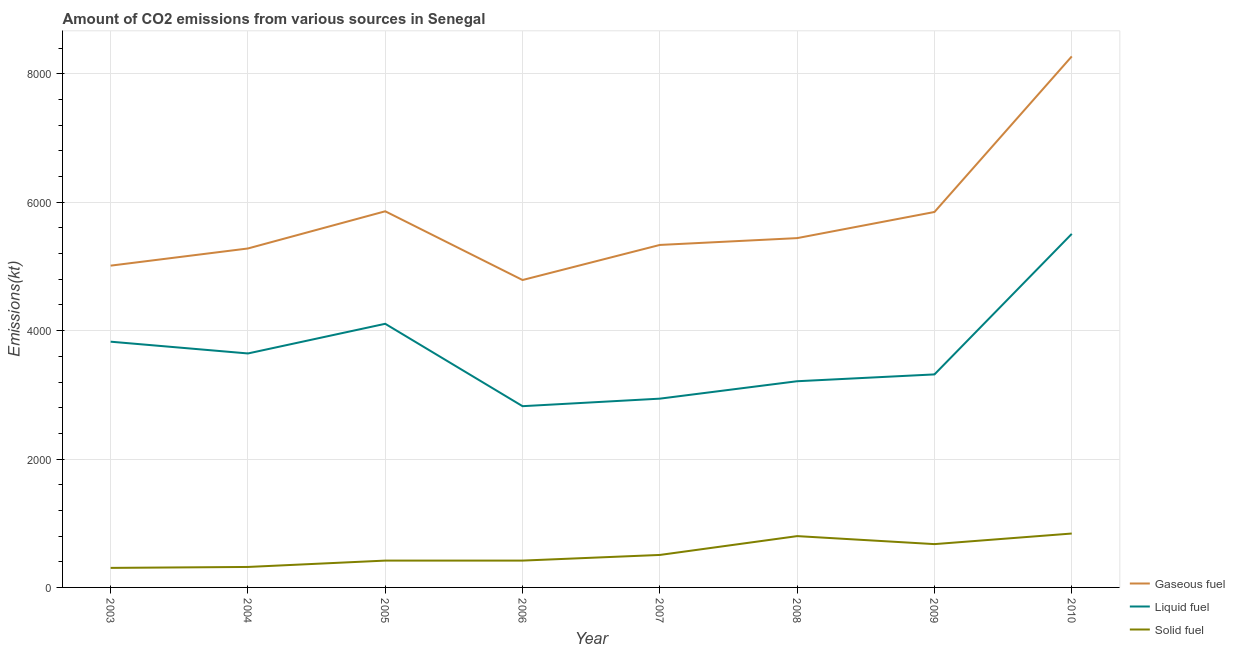How many different coloured lines are there?
Provide a succinct answer. 3. Does the line corresponding to amount of co2 emissions from gaseous fuel intersect with the line corresponding to amount of co2 emissions from solid fuel?
Keep it short and to the point. No. What is the amount of co2 emissions from liquid fuel in 2005?
Offer a very short reply. 4107.04. Across all years, what is the maximum amount of co2 emissions from gaseous fuel?
Give a very brief answer. 8272.75. Across all years, what is the minimum amount of co2 emissions from solid fuel?
Make the answer very short. 304.36. In which year was the amount of co2 emissions from solid fuel minimum?
Offer a terse response. 2003. What is the total amount of co2 emissions from gaseous fuel in the graph?
Offer a terse response. 4.58e+04. What is the difference between the amount of co2 emissions from gaseous fuel in 2004 and that in 2006?
Offer a very short reply. 491.38. What is the difference between the amount of co2 emissions from gaseous fuel in 2008 and the amount of co2 emissions from liquid fuel in 2004?
Make the answer very short. 1796.83. What is the average amount of co2 emissions from liquid fuel per year?
Give a very brief answer. 3672.96. In the year 2007, what is the difference between the amount of co2 emissions from liquid fuel and amount of co2 emissions from gaseous fuel?
Keep it short and to the point. -2394.55. What is the ratio of the amount of co2 emissions from gaseous fuel in 2003 to that in 2007?
Give a very brief answer. 0.94. Is the difference between the amount of co2 emissions from gaseous fuel in 2003 and 2005 greater than the difference between the amount of co2 emissions from solid fuel in 2003 and 2005?
Your response must be concise. No. What is the difference between the highest and the second highest amount of co2 emissions from gaseous fuel?
Keep it short and to the point. 2412.89. What is the difference between the highest and the lowest amount of co2 emissions from solid fuel?
Make the answer very short. 535.38. Does the amount of co2 emissions from gaseous fuel monotonically increase over the years?
Your answer should be very brief. No. Is the amount of co2 emissions from gaseous fuel strictly greater than the amount of co2 emissions from solid fuel over the years?
Offer a terse response. Yes. How many lines are there?
Your response must be concise. 3. Are the values on the major ticks of Y-axis written in scientific E-notation?
Ensure brevity in your answer.  No. Does the graph contain any zero values?
Offer a very short reply. No. Does the graph contain grids?
Your answer should be compact. Yes. Where does the legend appear in the graph?
Your response must be concise. Bottom right. How many legend labels are there?
Ensure brevity in your answer.  3. How are the legend labels stacked?
Offer a very short reply. Vertical. What is the title of the graph?
Provide a succinct answer. Amount of CO2 emissions from various sources in Senegal. Does "Poland" appear as one of the legend labels in the graph?
Your response must be concise. No. What is the label or title of the X-axis?
Make the answer very short. Year. What is the label or title of the Y-axis?
Offer a terse response. Emissions(kt). What is the Emissions(kt) of Gaseous fuel in 2003?
Your response must be concise. 5012.79. What is the Emissions(kt) in Liquid fuel in 2003?
Your answer should be compact. 3828.35. What is the Emissions(kt) in Solid fuel in 2003?
Make the answer very short. 304.36. What is the Emissions(kt) in Gaseous fuel in 2004?
Offer a terse response. 5280.48. What is the Emissions(kt) in Liquid fuel in 2004?
Your answer should be compact. 3645. What is the Emissions(kt) of Solid fuel in 2004?
Make the answer very short. 319.03. What is the Emissions(kt) in Gaseous fuel in 2005?
Your answer should be compact. 5859.87. What is the Emissions(kt) of Liquid fuel in 2005?
Provide a short and direct response. 4107.04. What is the Emissions(kt) in Solid fuel in 2005?
Ensure brevity in your answer.  418.04. What is the Emissions(kt) of Gaseous fuel in 2006?
Your response must be concise. 4789.1. What is the Emissions(kt) of Liquid fuel in 2006?
Your response must be concise. 2823.59. What is the Emissions(kt) of Solid fuel in 2006?
Your answer should be very brief. 418.04. What is the Emissions(kt) of Gaseous fuel in 2007?
Give a very brief answer. 5335.48. What is the Emissions(kt) of Liquid fuel in 2007?
Give a very brief answer. 2940.93. What is the Emissions(kt) in Solid fuel in 2007?
Keep it short and to the point. 506.05. What is the Emissions(kt) in Gaseous fuel in 2008?
Keep it short and to the point. 5441.83. What is the Emissions(kt) in Liquid fuel in 2008?
Make the answer very short. 3212.29. What is the Emissions(kt) in Solid fuel in 2008?
Provide a succinct answer. 799.41. What is the Emissions(kt) in Gaseous fuel in 2009?
Offer a terse response. 5848.86. What is the Emissions(kt) of Liquid fuel in 2009?
Provide a short and direct response. 3318.64. What is the Emissions(kt) of Solid fuel in 2009?
Your answer should be compact. 674.73. What is the Emissions(kt) in Gaseous fuel in 2010?
Your response must be concise. 8272.75. What is the Emissions(kt) of Liquid fuel in 2010?
Keep it short and to the point. 5507.83. What is the Emissions(kt) in Solid fuel in 2010?
Provide a short and direct response. 839.74. Across all years, what is the maximum Emissions(kt) in Gaseous fuel?
Provide a succinct answer. 8272.75. Across all years, what is the maximum Emissions(kt) in Liquid fuel?
Your answer should be compact. 5507.83. Across all years, what is the maximum Emissions(kt) in Solid fuel?
Your response must be concise. 839.74. Across all years, what is the minimum Emissions(kt) in Gaseous fuel?
Offer a terse response. 4789.1. Across all years, what is the minimum Emissions(kt) of Liquid fuel?
Offer a very short reply. 2823.59. Across all years, what is the minimum Emissions(kt) in Solid fuel?
Your response must be concise. 304.36. What is the total Emissions(kt) of Gaseous fuel in the graph?
Ensure brevity in your answer.  4.58e+04. What is the total Emissions(kt) in Liquid fuel in the graph?
Give a very brief answer. 2.94e+04. What is the total Emissions(kt) in Solid fuel in the graph?
Provide a short and direct response. 4279.39. What is the difference between the Emissions(kt) in Gaseous fuel in 2003 and that in 2004?
Give a very brief answer. -267.69. What is the difference between the Emissions(kt) of Liquid fuel in 2003 and that in 2004?
Ensure brevity in your answer.  183.35. What is the difference between the Emissions(kt) of Solid fuel in 2003 and that in 2004?
Provide a succinct answer. -14.67. What is the difference between the Emissions(kt) of Gaseous fuel in 2003 and that in 2005?
Give a very brief answer. -847.08. What is the difference between the Emissions(kt) in Liquid fuel in 2003 and that in 2005?
Provide a succinct answer. -278.69. What is the difference between the Emissions(kt) of Solid fuel in 2003 and that in 2005?
Your answer should be compact. -113.68. What is the difference between the Emissions(kt) of Gaseous fuel in 2003 and that in 2006?
Your response must be concise. 223.69. What is the difference between the Emissions(kt) of Liquid fuel in 2003 and that in 2006?
Offer a terse response. 1004.76. What is the difference between the Emissions(kt) of Solid fuel in 2003 and that in 2006?
Offer a terse response. -113.68. What is the difference between the Emissions(kt) in Gaseous fuel in 2003 and that in 2007?
Make the answer very short. -322.7. What is the difference between the Emissions(kt) of Liquid fuel in 2003 and that in 2007?
Provide a succinct answer. 887.41. What is the difference between the Emissions(kt) of Solid fuel in 2003 and that in 2007?
Provide a short and direct response. -201.69. What is the difference between the Emissions(kt) of Gaseous fuel in 2003 and that in 2008?
Your answer should be very brief. -429.04. What is the difference between the Emissions(kt) of Liquid fuel in 2003 and that in 2008?
Your answer should be very brief. 616.06. What is the difference between the Emissions(kt) of Solid fuel in 2003 and that in 2008?
Offer a very short reply. -495.05. What is the difference between the Emissions(kt) in Gaseous fuel in 2003 and that in 2009?
Offer a terse response. -836.08. What is the difference between the Emissions(kt) of Liquid fuel in 2003 and that in 2009?
Offer a terse response. 509.71. What is the difference between the Emissions(kt) of Solid fuel in 2003 and that in 2009?
Give a very brief answer. -370.37. What is the difference between the Emissions(kt) in Gaseous fuel in 2003 and that in 2010?
Keep it short and to the point. -3259.96. What is the difference between the Emissions(kt) of Liquid fuel in 2003 and that in 2010?
Offer a terse response. -1679.49. What is the difference between the Emissions(kt) in Solid fuel in 2003 and that in 2010?
Your answer should be compact. -535.38. What is the difference between the Emissions(kt) of Gaseous fuel in 2004 and that in 2005?
Your response must be concise. -579.39. What is the difference between the Emissions(kt) of Liquid fuel in 2004 and that in 2005?
Your response must be concise. -462.04. What is the difference between the Emissions(kt) in Solid fuel in 2004 and that in 2005?
Your answer should be compact. -99.01. What is the difference between the Emissions(kt) of Gaseous fuel in 2004 and that in 2006?
Your answer should be compact. 491.38. What is the difference between the Emissions(kt) in Liquid fuel in 2004 and that in 2006?
Give a very brief answer. 821.41. What is the difference between the Emissions(kt) of Solid fuel in 2004 and that in 2006?
Your answer should be compact. -99.01. What is the difference between the Emissions(kt) of Gaseous fuel in 2004 and that in 2007?
Keep it short and to the point. -55.01. What is the difference between the Emissions(kt) of Liquid fuel in 2004 and that in 2007?
Provide a succinct answer. 704.06. What is the difference between the Emissions(kt) of Solid fuel in 2004 and that in 2007?
Offer a very short reply. -187.02. What is the difference between the Emissions(kt) in Gaseous fuel in 2004 and that in 2008?
Make the answer very short. -161.35. What is the difference between the Emissions(kt) of Liquid fuel in 2004 and that in 2008?
Make the answer very short. 432.71. What is the difference between the Emissions(kt) in Solid fuel in 2004 and that in 2008?
Your response must be concise. -480.38. What is the difference between the Emissions(kt) in Gaseous fuel in 2004 and that in 2009?
Your answer should be compact. -568.38. What is the difference between the Emissions(kt) of Liquid fuel in 2004 and that in 2009?
Offer a terse response. 326.36. What is the difference between the Emissions(kt) in Solid fuel in 2004 and that in 2009?
Offer a very short reply. -355.7. What is the difference between the Emissions(kt) in Gaseous fuel in 2004 and that in 2010?
Give a very brief answer. -2992.27. What is the difference between the Emissions(kt) of Liquid fuel in 2004 and that in 2010?
Make the answer very short. -1862.84. What is the difference between the Emissions(kt) in Solid fuel in 2004 and that in 2010?
Your answer should be compact. -520.71. What is the difference between the Emissions(kt) of Gaseous fuel in 2005 and that in 2006?
Your response must be concise. 1070.76. What is the difference between the Emissions(kt) of Liquid fuel in 2005 and that in 2006?
Provide a succinct answer. 1283.45. What is the difference between the Emissions(kt) in Gaseous fuel in 2005 and that in 2007?
Give a very brief answer. 524.38. What is the difference between the Emissions(kt) of Liquid fuel in 2005 and that in 2007?
Provide a succinct answer. 1166.11. What is the difference between the Emissions(kt) of Solid fuel in 2005 and that in 2007?
Keep it short and to the point. -88.01. What is the difference between the Emissions(kt) in Gaseous fuel in 2005 and that in 2008?
Offer a very short reply. 418.04. What is the difference between the Emissions(kt) of Liquid fuel in 2005 and that in 2008?
Give a very brief answer. 894.75. What is the difference between the Emissions(kt) in Solid fuel in 2005 and that in 2008?
Provide a short and direct response. -381.37. What is the difference between the Emissions(kt) of Gaseous fuel in 2005 and that in 2009?
Your response must be concise. 11. What is the difference between the Emissions(kt) of Liquid fuel in 2005 and that in 2009?
Your answer should be very brief. 788.4. What is the difference between the Emissions(kt) in Solid fuel in 2005 and that in 2009?
Your answer should be very brief. -256.69. What is the difference between the Emissions(kt) in Gaseous fuel in 2005 and that in 2010?
Give a very brief answer. -2412.89. What is the difference between the Emissions(kt) in Liquid fuel in 2005 and that in 2010?
Provide a succinct answer. -1400.79. What is the difference between the Emissions(kt) of Solid fuel in 2005 and that in 2010?
Your response must be concise. -421.7. What is the difference between the Emissions(kt) of Gaseous fuel in 2006 and that in 2007?
Your answer should be very brief. -546.38. What is the difference between the Emissions(kt) of Liquid fuel in 2006 and that in 2007?
Provide a short and direct response. -117.34. What is the difference between the Emissions(kt) of Solid fuel in 2006 and that in 2007?
Make the answer very short. -88.01. What is the difference between the Emissions(kt) in Gaseous fuel in 2006 and that in 2008?
Provide a short and direct response. -652.73. What is the difference between the Emissions(kt) of Liquid fuel in 2006 and that in 2008?
Ensure brevity in your answer.  -388.7. What is the difference between the Emissions(kt) in Solid fuel in 2006 and that in 2008?
Provide a succinct answer. -381.37. What is the difference between the Emissions(kt) in Gaseous fuel in 2006 and that in 2009?
Your answer should be very brief. -1059.76. What is the difference between the Emissions(kt) in Liquid fuel in 2006 and that in 2009?
Offer a terse response. -495.05. What is the difference between the Emissions(kt) of Solid fuel in 2006 and that in 2009?
Keep it short and to the point. -256.69. What is the difference between the Emissions(kt) of Gaseous fuel in 2006 and that in 2010?
Offer a very short reply. -3483.65. What is the difference between the Emissions(kt) in Liquid fuel in 2006 and that in 2010?
Offer a terse response. -2684.24. What is the difference between the Emissions(kt) in Solid fuel in 2006 and that in 2010?
Your answer should be very brief. -421.7. What is the difference between the Emissions(kt) of Gaseous fuel in 2007 and that in 2008?
Provide a short and direct response. -106.34. What is the difference between the Emissions(kt) of Liquid fuel in 2007 and that in 2008?
Provide a short and direct response. -271.36. What is the difference between the Emissions(kt) in Solid fuel in 2007 and that in 2008?
Provide a succinct answer. -293.36. What is the difference between the Emissions(kt) in Gaseous fuel in 2007 and that in 2009?
Provide a succinct answer. -513.38. What is the difference between the Emissions(kt) in Liquid fuel in 2007 and that in 2009?
Provide a short and direct response. -377.7. What is the difference between the Emissions(kt) of Solid fuel in 2007 and that in 2009?
Provide a succinct answer. -168.68. What is the difference between the Emissions(kt) in Gaseous fuel in 2007 and that in 2010?
Your answer should be compact. -2937.27. What is the difference between the Emissions(kt) in Liquid fuel in 2007 and that in 2010?
Give a very brief answer. -2566.9. What is the difference between the Emissions(kt) of Solid fuel in 2007 and that in 2010?
Your answer should be very brief. -333.7. What is the difference between the Emissions(kt) in Gaseous fuel in 2008 and that in 2009?
Ensure brevity in your answer.  -407.04. What is the difference between the Emissions(kt) in Liquid fuel in 2008 and that in 2009?
Provide a short and direct response. -106.34. What is the difference between the Emissions(kt) in Solid fuel in 2008 and that in 2009?
Your answer should be compact. 124.68. What is the difference between the Emissions(kt) of Gaseous fuel in 2008 and that in 2010?
Ensure brevity in your answer.  -2830.92. What is the difference between the Emissions(kt) of Liquid fuel in 2008 and that in 2010?
Ensure brevity in your answer.  -2295.54. What is the difference between the Emissions(kt) of Solid fuel in 2008 and that in 2010?
Provide a succinct answer. -40.34. What is the difference between the Emissions(kt) in Gaseous fuel in 2009 and that in 2010?
Provide a succinct answer. -2423.89. What is the difference between the Emissions(kt) in Liquid fuel in 2009 and that in 2010?
Offer a terse response. -2189.2. What is the difference between the Emissions(kt) of Solid fuel in 2009 and that in 2010?
Make the answer very short. -165.01. What is the difference between the Emissions(kt) in Gaseous fuel in 2003 and the Emissions(kt) in Liquid fuel in 2004?
Give a very brief answer. 1367.79. What is the difference between the Emissions(kt) in Gaseous fuel in 2003 and the Emissions(kt) in Solid fuel in 2004?
Make the answer very short. 4693.76. What is the difference between the Emissions(kt) in Liquid fuel in 2003 and the Emissions(kt) in Solid fuel in 2004?
Keep it short and to the point. 3509.32. What is the difference between the Emissions(kt) in Gaseous fuel in 2003 and the Emissions(kt) in Liquid fuel in 2005?
Your answer should be compact. 905.75. What is the difference between the Emissions(kt) in Gaseous fuel in 2003 and the Emissions(kt) in Solid fuel in 2005?
Keep it short and to the point. 4594.75. What is the difference between the Emissions(kt) of Liquid fuel in 2003 and the Emissions(kt) of Solid fuel in 2005?
Your answer should be compact. 3410.31. What is the difference between the Emissions(kt) of Gaseous fuel in 2003 and the Emissions(kt) of Liquid fuel in 2006?
Make the answer very short. 2189.2. What is the difference between the Emissions(kt) of Gaseous fuel in 2003 and the Emissions(kt) of Solid fuel in 2006?
Give a very brief answer. 4594.75. What is the difference between the Emissions(kt) in Liquid fuel in 2003 and the Emissions(kt) in Solid fuel in 2006?
Provide a short and direct response. 3410.31. What is the difference between the Emissions(kt) of Gaseous fuel in 2003 and the Emissions(kt) of Liquid fuel in 2007?
Make the answer very short. 2071.86. What is the difference between the Emissions(kt) in Gaseous fuel in 2003 and the Emissions(kt) in Solid fuel in 2007?
Provide a short and direct response. 4506.74. What is the difference between the Emissions(kt) of Liquid fuel in 2003 and the Emissions(kt) of Solid fuel in 2007?
Provide a short and direct response. 3322.3. What is the difference between the Emissions(kt) in Gaseous fuel in 2003 and the Emissions(kt) in Liquid fuel in 2008?
Your answer should be very brief. 1800.5. What is the difference between the Emissions(kt) of Gaseous fuel in 2003 and the Emissions(kt) of Solid fuel in 2008?
Your answer should be very brief. 4213.38. What is the difference between the Emissions(kt) in Liquid fuel in 2003 and the Emissions(kt) in Solid fuel in 2008?
Offer a terse response. 3028.94. What is the difference between the Emissions(kt) in Gaseous fuel in 2003 and the Emissions(kt) in Liquid fuel in 2009?
Offer a very short reply. 1694.15. What is the difference between the Emissions(kt) of Gaseous fuel in 2003 and the Emissions(kt) of Solid fuel in 2009?
Offer a terse response. 4338.06. What is the difference between the Emissions(kt) of Liquid fuel in 2003 and the Emissions(kt) of Solid fuel in 2009?
Your answer should be very brief. 3153.62. What is the difference between the Emissions(kt) of Gaseous fuel in 2003 and the Emissions(kt) of Liquid fuel in 2010?
Offer a terse response. -495.05. What is the difference between the Emissions(kt) of Gaseous fuel in 2003 and the Emissions(kt) of Solid fuel in 2010?
Make the answer very short. 4173.05. What is the difference between the Emissions(kt) of Liquid fuel in 2003 and the Emissions(kt) of Solid fuel in 2010?
Provide a succinct answer. 2988.61. What is the difference between the Emissions(kt) in Gaseous fuel in 2004 and the Emissions(kt) in Liquid fuel in 2005?
Your answer should be compact. 1173.44. What is the difference between the Emissions(kt) in Gaseous fuel in 2004 and the Emissions(kt) in Solid fuel in 2005?
Offer a terse response. 4862.44. What is the difference between the Emissions(kt) in Liquid fuel in 2004 and the Emissions(kt) in Solid fuel in 2005?
Provide a short and direct response. 3226.96. What is the difference between the Emissions(kt) in Gaseous fuel in 2004 and the Emissions(kt) in Liquid fuel in 2006?
Give a very brief answer. 2456.89. What is the difference between the Emissions(kt) of Gaseous fuel in 2004 and the Emissions(kt) of Solid fuel in 2006?
Offer a very short reply. 4862.44. What is the difference between the Emissions(kt) of Liquid fuel in 2004 and the Emissions(kt) of Solid fuel in 2006?
Your answer should be compact. 3226.96. What is the difference between the Emissions(kt) of Gaseous fuel in 2004 and the Emissions(kt) of Liquid fuel in 2007?
Your response must be concise. 2339.55. What is the difference between the Emissions(kt) in Gaseous fuel in 2004 and the Emissions(kt) in Solid fuel in 2007?
Your answer should be compact. 4774.43. What is the difference between the Emissions(kt) in Liquid fuel in 2004 and the Emissions(kt) in Solid fuel in 2007?
Offer a very short reply. 3138.95. What is the difference between the Emissions(kt) of Gaseous fuel in 2004 and the Emissions(kt) of Liquid fuel in 2008?
Your response must be concise. 2068.19. What is the difference between the Emissions(kt) in Gaseous fuel in 2004 and the Emissions(kt) in Solid fuel in 2008?
Offer a very short reply. 4481.07. What is the difference between the Emissions(kt) of Liquid fuel in 2004 and the Emissions(kt) of Solid fuel in 2008?
Ensure brevity in your answer.  2845.59. What is the difference between the Emissions(kt) in Gaseous fuel in 2004 and the Emissions(kt) in Liquid fuel in 2009?
Offer a very short reply. 1961.85. What is the difference between the Emissions(kt) in Gaseous fuel in 2004 and the Emissions(kt) in Solid fuel in 2009?
Provide a short and direct response. 4605.75. What is the difference between the Emissions(kt) in Liquid fuel in 2004 and the Emissions(kt) in Solid fuel in 2009?
Your answer should be compact. 2970.27. What is the difference between the Emissions(kt) of Gaseous fuel in 2004 and the Emissions(kt) of Liquid fuel in 2010?
Your answer should be compact. -227.35. What is the difference between the Emissions(kt) of Gaseous fuel in 2004 and the Emissions(kt) of Solid fuel in 2010?
Give a very brief answer. 4440.74. What is the difference between the Emissions(kt) of Liquid fuel in 2004 and the Emissions(kt) of Solid fuel in 2010?
Your answer should be compact. 2805.26. What is the difference between the Emissions(kt) of Gaseous fuel in 2005 and the Emissions(kt) of Liquid fuel in 2006?
Make the answer very short. 3036.28. What is the difference between the Emissions(kt) of Gaseous fuel in 2005 and the Emissions(kt) of Solid fuel in 2006?
Provide a short and direct response. 5441.83. What is the difference between the Emissions(kt) in Liquid fuel in 2005 and the Emissions(kt) in Solid fuel in 2006?
Offer a terse response. 3689. What is the difference between the Emissions(kt) in Gaseous fuel in 2005 and the Emissions(kt) in Liquid fuel in 2007?
Your answer should be compact. 2918.93. What is the difference between the Emissions(kt) in Gaseous fuel in 2005 and the Emissions(kt) in Solid fuel in 2007?
Keep it short and to the point. 5353.82. What is the difference between the Emissions(kt) in Liquid fuel in 2005 and the Emissions(kt) in Solid fuel in 2007?
Make the answer very short. 3600.99. What is the difference between the Emissions(kt) of Gaseous fuel in 2005 and the Emissions(kt) of Liquid fuel in 2008?
Give a very brief answer. 2647.57. What is the difference between the Emissions(kt) of Gaseous fuel in 2005 and the Emissions(kt) of Solid fuel in 2008?
Provide a short and direct response. 5060.46. What is the difference between the Emissions(kt) in Liquid fuel in 2005 and the Emissions(kt) in Solid fuel in 2008?
Ensure brevity in your answer.  3307.63. What is the difference between the Emissions(kt) in Gaseous fuel in 2005 and the Emissions(kt) in Liquid fuel in 2009?
Ensure brevity in your answer.  2541.23. What is the difference between the Emissions(kt) of Gaseous fuel in 2005 and the Emissions(kt) of Solid fuel in 2009?
Offer a very short reply. 5185.14. What is the difference between the Emissions(kt) of Liquid fuel in 2005 and the Emissions(kt) of Solid fuel in 2009?
Provide a succinct answer. 3432.31. What is the difference between the Emissions(kt) of Gaseous fuel in 2005 and the Emissions(kt) of Liquid fuel in 2010?
Make the answer very short. 352.03. What is the difference between the Emissions(kt) of Gaseous fuel in 2005 and the Emissions(kt) of Solid fuel in 2010?
Offer a terse response. 5020.12. What is the difference between the Emissions(kt) of Liquid fuel in 2005 and the Emissions(kt) of Solid fuel in 2010?
Keep it short and to the point. 3267.3. What is the difference between the Emissions(kt) in Gaseous fuel in 2006 and the Emissions(kt) in Liquid fuel in 2007?
Give a very brief answer. 1848.17. What is the difference between the Emissions(kt) in Gaseous fuel in 2006 and the Emissions(kt) in Solid fuel in 2007?
Your response must be concise. 4283.06. What is the difference between the Emissions(kt) in Liquid fuel in 2006 and the Emissions(kt) in Solid fuel in 2007?
Offer a very short reply. 2317.54. What is the difference between the Emissions(kt) of Gaseous fuel in 2006 and the Emissions(kt) of Liquid fuel in 2008?
Your answer should be compact. 1576.81. What is the difference between the Emissions(kt) of Gaseous fuel in 2006 and the Emissions(kt) of Solid fuel in 2008?
Offer a very short reply. 3989.7. What is the difference between the Emissions(kt) in Liquid fuel in 2006 and the Emissions(kt) in Solid fuel in 2008?
Your response must be concise. 2024.18. What is the difference between the Emissions(kt) in Gaseous fuel in 2006 and the Emissions(kt) in Liquid fuel in 2009?
Provide a succinct answer. 1470.47. What is the difference between the Emissions(kt) of Gaseous fuel in 2006 and the Emissions(kt) of Solid fuel in 2009?
Ensure brevity in your answer.  4114.37. What is the difference between the Emissions(kt) of Liquid fuel in 2006 and the Emissions(kt) of Solid fuel in 2009?
Provide a succinct answer. 2148.86. What is the difference between the Emissions(kt) in Gaseous fuel in 2006 and the Emissions(kt) in Liquid fuel in 2010?
Offer a very short reply. -718.73. What is the difference between the Emissions(kt) of Gaseous fuel in 2006 and the Emissions(kt) of Solid fuel in 2010?
Offer a terse response. 3949.36. What is the difference between the Emissions(kt) in Liquid fuel in 2006 and the Emissions(kt) in Solid fuel in 2010?
Make the answer very short. 1983.85. What is the difference between the Emissions(kt) in Gaseous fuel in 2007 and the Emissions(kt) in Liquid fuel in 2008?
Provide a succinct answer. 2123.19. What is the difference between the Emissions(kt) in Gaseous fuel in 2007 and the Emissions(kt) in Solid fuel in 2008?
Your response must be concise. 4536.08. What is the difference between the Emissions(kt) of Liquid fuel in 2007 and the Emissions(kt) of Solid fuel in 2008?
Provide a succinct answer. 2141.53. What is the difference between the Emissions(kt) in Gaseous fuel in 2007 and the Emissions(kt) in Liquid fuel in 2009?
Keep it short and to the point. 2016.85. What is the difference between the Emissions(kt) in Gaseous fuel in 2007 and the Emissions(kt) in Solid fuel in 2009?
Offer a terse response. 4660.76. What is the difference between the Emissions(kt) of Liquid fuel in 2007 and the Emissions(kt) of Solid fuel in 2009?
Provide a short and direct response. 2266.21. What is the difference between the Emissions(kt) in Gaseous fuel in 2007 and the Emissions(kt) in Liquid fuel in 2010?
Offer a terse response. -172.35. What is the difference between the Emissions(kt) of Gaseous fuel in 2007 and the Emissions(kt) of Solid fuel in 2010?
Provide a succinct answer. 4495.74. What is the difference between the Emissions(kt) in Liquid fuel in 2007 and the Emissions(kt) in Solid fuel in 2010?
Provide a short and direct response. 2101.19. What is the difference between the Emissions(kt) in Gaseous fuel in 2008 and the Emissions(kt) in Liquid fuel in 2009?
Make the answer very short. 2123.19. What is the difference between the Emissions(kt) in Gaseous fuel in 2008 and the Emissions(kt) in Solid fuel in 2009?
Provide a succinct answer. 4767.1. What is the difference between the Emissions(kt) in Liquid fuel in 2008 and the Emissions(kt) in Solid fuel in 2009?
Provide a succinct answer. 2537.56. What is the difference between the Emissions(kt) of Gaseous fuel in 2008 and the Emissions(kt) of Liquid fuel in 2010?
Keep it short and to the point. -66.01. What is the difference between the Emissions(kt) in Gaseous fuel in 2008 and the Emissions(kt) in Solid fuel in 2010?
Your answer should be very brief. 4602.09. What is the difference between the Emissions(kt) of Liquid fuel in 2008 and the Emissions(kt) of Solid fuel in 2010?
Your response must be concise. 2372.55. What is the difference between the Emissions(kt) in Gaseous fuel in 2009 and the Emissions(kt) in Liquid fuel in 2010?
Your answer should be compact. 341.03. What is the difference between the Emissions(kt) in Gaseous fuel in 2009 and the Emissions(kt) in Solid fuel in 2010?
Ensure brevity in your answer.  5009.12. What is the difference between the Emissions(kt) in Liquid fuel in 2009 and the Emissions(kt) in Solid fuel in 2010?
Provide a short and direct response. 2478.89. What is the average Emissions(kt) in Gaseous fuel per year?
Give a very brief answer. 5730.15. What is the average Emissions(kt) in Liquid fuel per year?
Provide a short and direct response. 3672.96. What is the average Emissions(kt) in Solid fuel per year?
Ensure brevity in your answer.  534.92. In the year 2003, what is the difference between the Emissions(kt) in Gaseous fuel and Emissions(kt) in Liquid fuel?
Your answer should be compact. 1184.44. In the year 2003, what is the difference between the Emissions(kt) of Gaseous fuel and Emissions(kt) of Solid fuel?
Ensure brevity in your answer.  4708.43. In the year 2003, what is the difference between the Emissions(kt) of Liquid fuel and Emissions(kt) of Solid fuel?
Provide a short and direct response. 3523.99. In the year 2004, what is the difference between the Emissions(kt) of Gaseous fuel and Emissions(kt) of Liquid fuel?
Ensure brevity in your answer.  1635.48. In the year 2004, what is the difference between the Emissions(kt) of Gaseous fuel and Emissions(kt) of Solid fuel?
Your answer should be very brief. 4961.45. In the year 2004, what is the difference between the Emissions(kt) of Liquid fuel and Emissions(kt) of Solid fuel?
Give a very brief answer. 3325.97. In the year 2005, what is the difference between the Emissions(kt) of Gaseous fuel and Emissions(kt) of Liquid fuel?
Make the answer very short. 1752.83. In the year 2005, what is the difference between the Emissions(kt) of Gaseous fuel and Emissions(kt) of Solid fuel?
Your answer should be very brief. 5441.83. In the year 2005, what is the difference between the Emissions(kt) in Liquid fuel and Emissions(kt) in Solid fuel?
Ensure brevity in your answer.  3689. In the year 2006, what is the difference between the Emissions(kt) in Gaseous fuel and Emissions(kt) in Liquid fuel?
Offer a very short reply. 1965.51. In the year 2006, what is the difference between the Emissions(kt) in Gaseous fuel and Emissions(kt) in Solid fuel?
Your response must be concise. 4371.06. In the year 2006, what is the difference between the Emissions(kt) of Liquid fuel and Emissions(kt) of Solid fuel?
Offer a very short reply. 2405.55. In the year 2007, what is the difference between the Emissions(kt) of Gaseous fuel and Emissions(kt) of Liquid fuel?
Make the answer very short. 2394.55. In the year 2007, what is the difference between the Emissions(kt) in Gaseous fuel and Emissions(kt) in Solid fuel?
Offer a very short reply. 4829.44. In the year 2007, what is the difference between the Emissions(kt) of Liquid fuel and Emissions(kt) of Solid fuel?
Your answer should be compact. 2434.89. In the year 2008, what is the difference between the Emissions(kt) of Gaseous fuel and Emissions(kt) of Liquid fuel?
Offer a terse response. 2229.54. In the year 2008, what is the difference between the Emissions(kt) in Gaseous fuel and Emissions(kt) in Solid fuel?
Offer a terse response. 4642.42. In the year 2008, what is the difference between the Emissions(kt) in Liquid fuel and Emissions(kt) in Solid fuel?
Provide a short and direct response. 2412.89. In the year 2009, what is the difference between the Emissions(kt) in Gaseous fuel and Emissions(kt) in Liquid fuel?
Provide a succinct answer. 2530.23. In the year 2009, what is the difference between the Emissions(kt) in Gaseous fuel and Emissions(kt) in Solid fuel?
Ensure brevity in your answer.  5174.14. In the year 2009, what is the difference between the Emissions(kt) in Liquid fuel and Emissions(kt) in Solid fuel?
Give a very brief answer. 2643.91. In the year 2010, what is the difference between the Emissions(kt) in Gaseous fuel and Emissions(kt) in Liquid fuel?
Ensure brevity in your answer.  2764.92. In the year 2010, what is the difference between the Emissions(kt) of Gaseous fuel and Emissions(kt) of Solid fuel?
Offer a very short reply. 7433.01. In the year 2010, what is the difference between the Emissions(kt) of Liquid fuel and Emissions(kt) of Solid fuel?
Provide a succinct answer. 4668.09. What is the ratio of the Emissions(kt) of Gaseous fuel in 2003 to that in 2004?
Make the answer very short. 0.95. What is the ratio of the Emissions(kt) in Liquid fuel in 2003 to that in 2004?
Your answer should be very brief. 1.05. What is the ratio of the Emissions(kt) in Solid fuel in 2003 to that in 2004?
Make the answer very short. 0.95. What is the ratio of the Emissions(kt) of Gaseous fuel in 2003 to that in 2005?
Provide a short and direct response. 0.86. What is the ratio of the Emissions(kt) of Liquid fuel in 2003 to that in 2005?
Make the answer very short. 0.93. What is the ratio of the Emissions(kt) of Solid fuel in 2003 to that in 2005?
Your response must be concise. 0.73. What is the ratio of the Emissions(kt) of Gaseous fuel in 2003 to that in 2006?
Ensure brevity in your answer.  1.05. What is the ratio of the Emissions(kt) in Liquid fuel in 2003 to that in 2006?
Your answer should be compact. 1.36. What is the ratio of the Emissions(kt) in Solid fuel in 2003 to that in 2006?
Provide a short and direct response. 0.73. What is the ratio of the Emissions(kt) in Gaseous fuel in 2003 to that in 2007?
Your response must be concise. 0.94. What is the ratio of the Emissions(kt) of Liquid fuel in 2003 to that in 2007?
Give a very brief answer. 1.3. What is the ratio of the Emissions(kt) of Solid fuel in 2003 to that in 2007?
Offer a very short reply. 0.6. What is the ratio of the Emissions(kt) in Gaseous fuel in 2003 to that in 2008?
Your answer should be compact. 0.92. What is the ratio of the Emissions(kt) of Liquid fuel in 2003 to that in 2008?
Provide a short and direct response. 1.19. What is the ratio of the Emissions(kt) of Solid fuel in 2003 to that in 2008?
Provide a short and direct response. 0.38. What is the ratio of the Emissions(kt) of Gaseous fuel in 2003 to that in 2009?
Your response must be concise. 0.86. What is the ratio of the Emissions(kt) in Liquid fuel in 2003 to that in 2009?
Your response must be concise. 1.15. What is the ratio of the Emissions(kt) of Solid fuel in 2003 to that in 2009?
Give a very brief answer. 0.45. What is the ratio of the Emissions(kt) of Gaseous fuel in 2003 to that in 2010?
Your answer should be very brief. 0.61. What is the ratio of the Emissions(kt) in Liquid fuel in 2003 to that in 2010?
Keep it short and to the point. 0.7. What is the ratio of the Emissions(kt) in Solid fuel in 2003 to that in 2010?
Your answer should be compact. 0.36. What is the ratio of the Emissions(kt) in Gaseous fuel in 2004 to that in 2005?
Your response must be concise. 0.9. What is the ratio of the Emissions(kt) in Liquid fuel in 2004 to that in 2005?
Give a very brief answer. 0.89. What is the ratio of the Emissions(kt) in Solid fuel in 2004 to that in 2005?
Your response must be concise. 0.76. What is the ratio of the Emissions(kt) in Gaseous fuel in 2004 to that in 2006?
Keep it short and to the point. 1.1. What is the ratio of the Emissions(kt) in Liquid fuel in 2004 to that in 2006?
Offer a very short reply. 1.29. What is the ratio of the Emissions(kt) of Solid fuel in 2004 to that in 2006?
Your answer should be compact. 0.76. What is the ratio of the Emissions(kt) in Liquid fuel in 2004 to that in 2007?
Your answer should be very brief. 1.24. What is the ratio of the Emissions(kt) in Solid fuel in 2004 to that in 2007?
Make the answer very short. 0.63. What is the ratio of the Emissions(kt) of Gaseous fuel in 2004 to that in 2008?
Keep it short and to the point. 0.97. What is the ratio of the Emissions(kt) of Liquid fuel in 2004 to that in 2008?
Give a very brief answer. 1.13. What is the ratio of the Emissions(kt) in Solid fuel in 2004 to that in 2008?
Your answer should be very brief. 0.4. What is the ratio of the Emissions(kt) of Gaseous fuel in 2004 to that in 2009?
Offer a terse response. 0.9. What is the ratio of the Emissions(kt) in Liquid fuel in 2004 to that in 2009?
Provide a succinct answer. 1.1. What is the ratio of the Emissions(kt) of Solid fuel in 2004 to that in 2009?
Provide a short and direct response. 0.47. What is the ratio of the Emissions(kt) in Gaseous fuel in 2004 to that in 2010?
Provide a succinct answer. 0.64. What is the ratio of the Emissions(kt) of Liquid fuel in 2004 to that in 2010?
Your answer should be compact. 0.66. What is the ratio of the Emissions(kt) in Solid fuel in 2004 to that in 2010?
Provide a short and direct response. 0.38. What is the ratio of the Emissions(kt) of Gaseous fuel in 2005 to that in 2006?
Your response must be concise. 1.22. What is the ratio of the Emissions(kt) in Liquid fuel in 2005 to that in 2006?
Make the answer very short. 1.45. What is the ratio of the Emissions(kt) of Solid fuel in 2005 to that in 2006?
Ensure brevity in your answer.  1. What is the ratio of the Emissions(kt) of Gaseous fuel in 2005 to that in 2007?
Keep it short and to the point. 1.1. What is the ratio of the Emissions(kt) of Liquid fuel in 2005 to that in 2007?
Your answer should be very brief. 1.4. What is the ratio of the Emissions(kt) in Solid fuel in 2005 to that in 2007?
Ensure brevity in your answer.  0.83. What is the ratio of the Emissions(kt) of Gaseous fuel in 2005 to that in 2008?
Provide a succinct answer. 1.08. What is the ratio of the Emissions(kt) of Liquid fuel in 2005 to that in 2008?
Offer a very short reply. 1.28. What is the ratio of the Emissions(kt) in Solid fuel in 2005 to that in 2008?
Your answer should be compact. 0.52. What is the ratio of the Emissions(kt) in Liquid fuel in 2005 to that in 2009?
Offer a very short reply. 1.24. What is the ratio of the Emissions(kt) of Solid fuel in 2005 to that in 2009?
Provide a succinct answer. 0.62. What is the ratio of the Emissions(kt) of Gaseous fuel in 2005 to that in 2010?
Keep it short and to the point. 0.71. What is the ratio of the Emissions(kt) of Liquid fuel in 2005 to that in 2010?
Ensure brevity in your answer.  0.75. What is the ratio of the Emissions(kt) of Solid fuel in 2005 to that in 2010?
Your answer should be compact. 0.5. What is the ratio of the Emissions(kt) in Gaseous fuel in 2006 to that in 2007?
Provide a short and direct response. 0.9. What is the ratio of the Emissions(kt) of Liquid fuel in 2006 to that in 2007?
Offer a terse response. 0.96. What is the ratio of the Emissions(kt) of Solid fuel in 2006 to that in 2007?
Keep it short and to the point. 0.83. What is the ratio of the Emissions(kt) of Gaseous fuel in 2006 to that in 2008?
Your answer should be very brief. 0.88. What is the ratio of the Emissions(kt) of Liquid fuel in 2006 to that in 2008?
Offer a very short reply. 0.88. What is the ratio of the Emissions(kt) of Solid fuel in 2006 to that in 2008?
Make the answer very short. 0.52. What is the ratio of the Emissions(kt) of Gaseous fuel in 2006 to that in 2009?
Provide a succinct answer. 0.82. What is the ratio of the Emissions(kt) of Liquid fuel in 2006 to that in 2009?
Make the answer very short. 0.85. What is the ratio of the Emissions(kt) of Solid fuel in 2006 to that in 2009?
Give a very brief answer. 0.62. What is the ratio of the Emissions(kt) of Gaseous fuel in 2006 to that in 2010?
Keep it short and to the point. 0.58. What is the ratio of the Emissions(kt) in Liquid fuel in 2006 to that in 2010?
Make the answer very short. 0.51. What is the ratio of the Emissions(kt) of Solid fuel in 2006 to that in 2010?
Offer a terse response. 0.5. What is the ratio of the Emissions(kt) in Gaseous fuel in 2007 to that in 2008?
Your response must be concise. 0.98. What is the ratio of the Emissions(kt) in Liquid fuel in 2007 to that in 2008?
Provide a short and direct response. 0.92. What is the ratio of the Emissions(kt) of Solid fuel in 2007 to that in 2008?
Keep it short and to the point. 0.63. What is the ratio of the Emissions(kt) of Gaseous fuel in 2007 to that in 2009?
Give a very brief answer. 0.91. What is the ratio of the Emissions(kt) of Liquid fuel in 2007 to that in 2009?
Ensure brevity in your answer.  0.89. What is the ratio of the Emissions(kt) in Gaseous fuel in 2007 to that in 2010?
Provide a short and direct response. 0.64. What is the ratio of the Emissions(kt) of Liquid fuel in 2007 to that in 2010?
Your answer should be very brief. 0.53. What is the ratio of the Emissions(kt) in Solid fuel in 2007 to that in 2010?
Your answer should be very brief. 0.6. What is the ratio of the Emissions(kt) in Gaseous fuel in 2008 to that in 2009?
Provide a succinct answer. 0.93. What is the ratio of the Emissions(kt) in Liquid fuel in 2008 to that in 2009?
Your answer should be compact. 0.97. What is the ratio of the Emissions(kt) of Solid fuel in 2008 to that in 2009?
Make the answer very short. 1.18. What is the ratio of the Emissions(kt) of Gaseous fuel in 2008 to that in 2010?
Your answer should be very brief. 0.66. What is the ratio of the Emissions(kt) in Liquid fuel in 2008 to that in 2010?
Your response must be concise. 0.58. What is the ratio of the Emissions(kt) in Gaseous fuel in 2009 to that in 2010?
Offer a terse response. 0.71. What is the ratio of the Emissions(kt) of Liquid fuel in 2009 to that in 2010?
Ensure brevity in your answer.  0.6. What is the ratio of the Emissions(kt) of Solid fuel in 2009 to that in 2010?
Your answer should be compact. 0.8. What is the difference between the highest and the second highest Emissions(kt) of Gaseous fuel?
Provide a short and direct response. 2412.89. What is the difference between the highest and the second highest Emissions(kt) in Liquid fuel?
Give a very brief answer. 1400.79. What is the difference between the highest and the second highest Emissions(kt) in Solid fuel?
Keep it short and to the point. 40.34. What is the difference between the highest and the lowest Emissions(kt) in Gaseous fuel?
Your answer should be compact. 3483.65. What is the difference between the highest and the lowest Emissions(kt) of Liquid fuel?
Ensure brevity in your answer.  2684.24. What is the difference between the highest and the lowest Emissions(kt) in Solid fuel?
Offer a terse response. 535.38. 